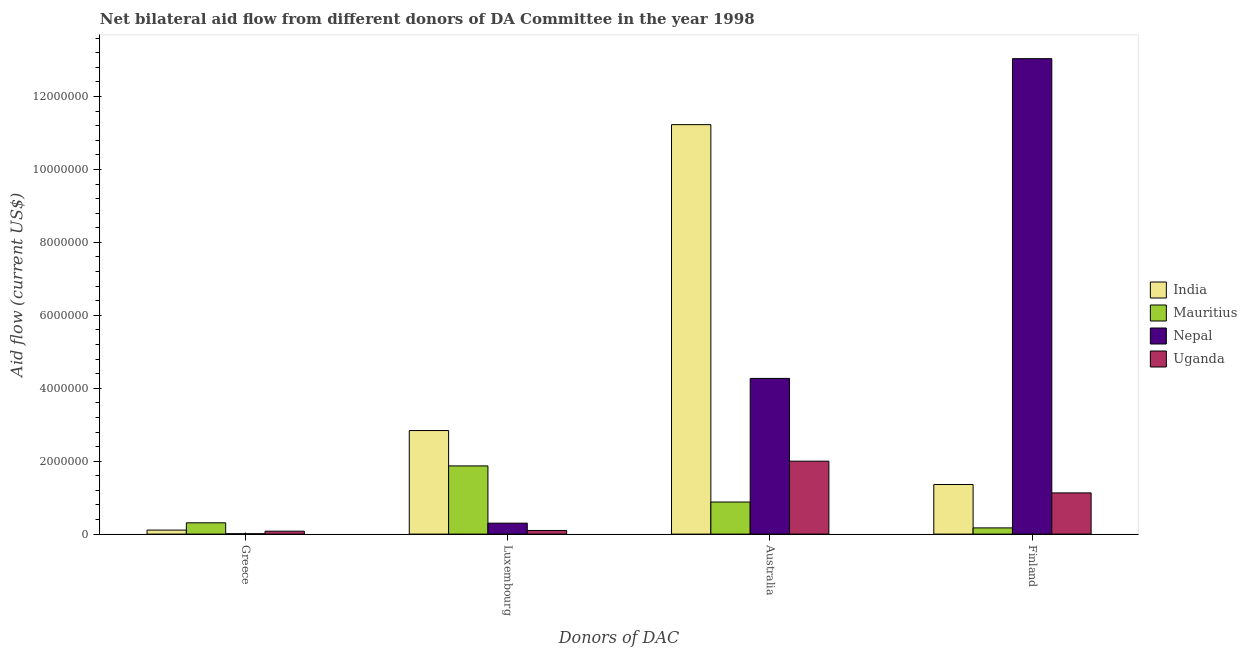What is the amount of aid given by greece in Mauritius?
Your answer should be compact. 3.10e+05. Across all countries, what is the maximum amount of aid given by luxembourg?
Provide a short and direct response. 2.84e+06. Across all countries, what is the minimum amount of aid given by greece?
Make the answer very short. 10000. In which country was the amount of aid given by finland minimum?
Ensure brevity in your answer.  Mauritius. What is the total amount of aid given by finland in the graph?
Your response must be concise. 1.57e+07. What is the difference between the amount of aid given by greece in Mauritius and that in India?
Ensure brevity in your answer.  2.00e+05. What is the difference between the amount of aid given by luxembourg in Nepal and the amount of aid given by finland in Mauritius?
Keep it short and to the point. 1.30e+05. What is the average amount of aid given by australia per country?
Give a very brief answer. 4.60e+06. What is the difference between the amount of aid given by luxembourg and amount of aid given by greece in Mauritius?
Give a very brief answer. 1.56e+06. In how many countries, is the amount of aid given by greece greater than 6400000 US$?
Your response must be concise. 0. What is the ratio of the amount of aid given by luxembourg in Uganda to that in Mauritius?
Give a very brief answer. 0.05. Is the amount of aid given by greece in Mauritius less than that in Nepal?
Provide a succinct answer. No. Is the difference between the amount of aid given by finland in India and Uganda greater than the difference between the amount of aid given by australia in India and Uganda?
Your answer should be compact. No. What is the difference between the highest and the second highest amount of aid given by finland?
Offer a very short reply. 1.17e+07. What is the difference between the highest and the lowest amount of aid given by luxembourg?
Offer a very short reply. 2.74e+06. In how many countries, is the amount of aid given by australia greater than the average amount of aid given by australia taken over all countries?
Offer a terse response. 1. Is it the case that in every country, the sum of the amount of aid given by finland and amount of aid given by luxembourg is greater than the sum of amount of aid given by australia and amount of aid given by greece?
Your answer should be very brief. No. What does the 3rd bar from the left in Australia represents?
Keep it short and to the point. Nepal. What does the 3rd bar from the right in Australia represents?
Your response must be concise. Mauritius. How many bars are there?
Keep it short and to the point. 16. Are all the bars in the graph horizontal?
Your answer should be compact. No. How many countries are there in the graph?
Offer a terse response. 4. Does the graph contain any zero values?
Your answer should be compact. No. How many legend labels are there?
Keep it short and to the point. 4. What is the title of the graph?
Your response must be concise. Net bilateral aid flow from different donors of DA Committee in the year 1998. What is the label or title of the X-axis?
Your answer should be very brief. Donors of DAC. What is the label or title of the Y-axis?
Make the answer very short. Aid flow (current US$). What is the Aid flow (current US$) of Nepal in Greece?
Offer a terse response. 10000. What is the Aid flow (current US$) of Uganda in Greece?
Make the answer very short. 8.00e+04. What is the Aid flow (current US$) of India in Luxembourg?
Offer a very short reply. 2.84e+06. What is the Aid flow (current US$) in Mauritius in Luxembourg?
Provide a short and direct response. 1.87e+06. What is the Aid flow (current US$) of India in Australia?
Your answer should be compact. 1.12e+07. What is the Aid flow (current US$) of Mauritius in Australia?
Offer a very short reply. 8.80e+05. What is the Aid flow (current US$) in Nepal in Australia?
Your answer should be very brief. 4.27e+06. What is the Aid flow (current US$) in India in Finland?
Offer a very short reply. 1.36e+06. What is the Aid flow (current US$) of Nepal in Finland?
Your answer should be very brief. 1.30e+07. What is the Aid flow (current US$) in Uganda in Finland?
Ensure brevity in your answer.  1.13e+06. Across all Donors of DAC, what is the maximum Aid flow (current US$) in India?
Make the answer very short. 1.12e+07. Across all Donors of DAC, what is the maximum Aid flow (current US$) in Mauritius?
Your answer should be compact. 1.87e+06. Across all Donors of DAC, what is the maximum Aid flow (current US$) of Nepal?
Your response must be concise. 1.30e+07. Across all Donors of DAC, what is the maximum Aid flow (current US$) of Uganda?
Ensure brevity in your answer.  2.00e+06. Across all Donors of DAC, what is the minimum Aid flow (current US$) in India?
Give a very brief answer. 1.10e+05. What is the total Aid flow (current US$) of India in the graph?
Provide a short and direct response. 1.55e+07. What is the total Aid flow (current US$) of Mauritius in the graph?
Your answer should be very brief. 3.23e+06. What is the total Aid flow (current US$) of Nepal in the graph?
Your response must be concise. 1.76e+07. What is the total Aid flow (current US$) of Uganda in the graph?
Give a very brief answer. 3.31e+06. What is the difference between the Aid flow (current US$) of India in Greece and that in Luxembourg?
Provide a succinct answer. -2.73e+06. What is the difference between the Aid flow (current US$) in Mauritius in Greece and that in Luxembourg?
Provide a succinct answer. -1.56e+06. What is the difference between the Aid flow (current US$) in Uganda in Greece and that in Luxembourg?
Your response must be concise. -2.00e+04. What is the difference between the Aid flow (current US$) in India in Greece and that in Australia?
Offer a very short reply. -1.11e+07. What is the difference between the Aid flow (current US$) of Mauritius in Greece and that in Australia?
Your answer should be very brief. -5.70e+05. What is the difference between the Aid flow (current US$) in Nepal in Greece and that in Australia?
Offer a very short reply. -4.26e+06. What is the difference between the Aid flow (current US$) of Uganda in Greece and that in Australia?
Your answer should be very brief. -1.92e+06. What is the difference between the Aid flow (current US$) in India in Greece and that in Finland?
Provide a short and direct response. -1.25e+06. What is the difference between the Aid flow (current US$) in Nepal in Greece and that in Finland?
Provide a succinct answer. -1.30e+07. What is the difference between the Aid flow (current US$) of Uganda in Greece and that in Finland?
Offer a very short reply. -1.05e+06. What is the difference between the Aid flow (current US$) of India in Luxembourg and that in Australia?
Give a very brief answer. -8.39e+06. What is the difference between the Aid flow (current US$) of Mauritius in Luxembourg and that in Australia?
Make the answer very short. 9.90e+05. What is the difference between the Aid flow (current US$) in Nepal in Luxembourg and that in Australia?
Offer a very short reply. -3.97e+06. What is the difference between the Aid flow (current US$) in Uganda in Luxembourg and that in Australia?
Keep it short and to the point. -1.90e+06. What is the difference between the Aid flow (current US$) in India in Luxembourg and that in Finland?
Provide a short and direct response. 1.48e+06. What is the difference between the Aid flow (current US$) in Mauritius in Luxembourg and that in Finland?
Provide a succinct answer. 1.70e+06. What is the difference between the Aid flow (current US$) of Nepal in Luxembourg and that in Finland?
Your answer should be compact. -1.27e+07. What is the difference between the Aid flow (current US$) of Uganda in Luxembourg and that in Finland?
Your answer should be compact. -1.03e+06. What is the difference between the Aid flow (current US$) in India in Australia and that in Finland?
Give a very brief answer. 9.87e+06. What is the difference between the Aid flow (current US$) in Mauritius in Australia and that in Finland?
Provide a short and direct response. 7.10e+05. What is the difference between the Aid flow (current US$) of Nepal in Australia and that in Finland?
Make the answer very short. -8.77e+06. What is the difference between the Aid flow (current US$) of Uganda in Australia and that in Finland?
Your answer should be very brief. 8.70e+05. What is the difference between the Aid flow (current US$) of India in Greece and the Aid flow (current US$) of Mauritius in Luxembourg?
Your answer should be compact. -1.76e+06. What is the difference between the Aid flow (current US$) of Mauritius in Greece and the Aid flow (current US$) of Uganda in Luxembourg?
Your answer should be compact. 2.10e+05. What is the difference between the Aid flow (current US$) in Nepal in Greece and the Aid flow (current US$) in Uganda in Luxembourg?
Ensure brevity in your answer.  -9.00e+04. What is the difference between the Aid flow (current US$) in India in Greece and the Aid flow (current US$) in Mauritius in Australia?
Your answer should be very brief. -7.70e+05. What is the difference between the Aid flow (current US$) in India in Greece and the Aid flow (current US$) in Nepal in Australia?
Your answer should be very brief. -4.16e+06. What is the difference between the Aid flow (current US$) in India in Greece and the Aid flow (current US$) in Uganda in Australia?
Offer a terse response. -1.89e+06. What is the difference between the Aid flow (current US$) of Mauritius in Greece and the Aid flow (current US$) of Nepal in Australia?
Provide a short and direct response. -3.96e+06. What is the difference between the Aid flow (current US$) of Mauritius in Greece and the Aid flow (current US$) of Uganda in Australia?
Offer a very short reply. -1.69e+06. What is the difference between the Aid flow (current US$) of Nepal in Greece and the Aid flow (current US$) of Uganda in Australia?
Your answer should be compact. -1.99e+06. What is the difference between the Aid flow (current US$) in India in Greece and the Aid flow (current US$) in Nepal in Finland?
Keep it short and to the point. -1.29e+07. What is the difference between the Aid flow (current US$) in India in Greece and the Aid flow (current US$) in Uganda in Finland?
Ensure brevity in your answer.  -1.02e+06. What is the difference between the Aid flow (current US$) in Mauritius in Greece and the Aid flow (current US$) in Nepal in Finland?
Offer a very short reply. -1.27e+07. What is the difference between the Aid flow (current US$) of Mauritius in Greece and the Aid flow (current US$) of Uganda in Finland?
Offer a terse response. -8.20e+05. What is the difference between the Aid flow (current US$) in Nepal in Greece and the Aid flow (current US$) in Uganda in Finland?
Ensure brevity in your answer.  -1.12e+06. What is the difference between the Aid flow (current US$) in India in Luxembourg and the Aid flow (current US$) in Mauritius in Australia?
Your response must be concise. 1.96e+06. What is the difference between the Aid flow (current US$) in India in Luxembourg and the Aid flow (current US$) in Nepal in Australia?
Your response must be concise. -1.43e+06. What is the difference between the Aid flow (current US$) in India in Luxembourg and the Aid flow (current US$) in Uganda in Australia?
Your answer should be compact. 8.40e+05. What is the difference between the Aid flow (current US$) in Mauritius in Luxembourg and the Aid flow (current US$) in Nepal in Australia?
Your answer should be very brief. -2.40e+06. What is the difference between the Aid flow (current US$) of Mauritius in Luxembourg and the Aid flow (current US$) of Uganda in Australia?
Offer a terse response. -1.30e+05. What is the difference between the Aid flow (current US$) in Nepal in Luxembourg and the Aid flow (current US$) in Uganda in Australia?
Ensure brevity in your answer.  -1.70e+06. What is the difference between the Aid flow (current US$) in India in Luxembourg and the Aid flow (current US$) in Mauritius in Finland?
Provide a short and direct response. 2.67e+06. What is the difference between the Aid flow (current US$) in India in Luxembourg and the Aid flow (current US$) in Nepal in Finland?
Your response must be concise. -1.02e+07. What is the difference between the Aid flow (current US$) in India in Luxembourg and the Aid flow (current US$) in Uganda in Finland?
Offer a terse response. 1.71e+06. What is the difference between the Aid flow (current US$) of Mauritius in Luxembourg and the Aid flow (current US$) of Nepal in Finland?
Your response must be concise. -1.12e+07. What is the difference between the Aid flow (current US$) in Mauritius in Luxembourg and the Aid flow (current US$) in Uganda in Finland?
Offer a terse response. 7.40e+05. What is the difference between the Aid flow (current US$) in Nepal in Luxembourg and the Aid flow (current US$) in Uganda in Finland?
Ensure brevity in your answer.  -8.30e+05. What is the difference between the Aid flow (current US$) of India in Australia and the Aid flow (current US$) of Mauritius in Finland?
Keep it short and to the point. 1.11e+07. What is the difference between the Aid flow (current US$) in India in Australia and the Aid flow (current US$) in Nepal in Finland?
Your answer should be very brief. -1.81e+06. What is the difference between the Aid flow (current US$) in India in Australia and the Aid flow (current US$) in Uganda in Finland?
Give a very brief answer. 1.01e+07. What is the difference between the Aid flow (current US$) of Mauritius in Australia and the Aid flow (current US$) of Nepal in Finland?
Your response must be concise. -1.22e+07. What is the difference between the Aid flow (current US$) in Mauritius in Australia and the Aid flow (current US$) in Uganda in Finland?
Provide a succinct answer. -2.50e+05. What is the difference between the Aid flow (current US$) of Nepal in Australia and the Aid flow (current US$) of Uganda in Finland?
Give a very brief answer. 3.14e+06. What is the average Aid flow (current US$) in India per Donors of DAC?
Give a very brief answer. 3.88e+06. What is the average Aid flow (current US$) of Mauritius per Donors of DAC?
Your response must be concise. 8.08e+05. What is the average Aid flow (current US$) in Nepal per Donors of DAC?
Your response must be concise. 4.40e+06. What is the average Aid flow (current US$) of Uganda per Donors of DAC?
Offer a very short reply. 8.28e+05. What is the difference between the Aid flow (current US$) in India and Aid flow (current US$) in Mauritius in Greece?
Your response must be concise. -2.00e+05. What is the difference between the Aid flow (current US$) of India and Aid flow (current US$) of Nepal in Greece?
Offer a terse response. 1.00e+05. What is the difference between the Aid flow (current US$) in India and Aid flow (current US$) in Uganda in Greece?
Keep it short and to the point. 3.00e+04. What is the difference between the Aid flow (current US$) of Mauritius and Aid flow (current US$) of Nepal in Greece?
Give a very brief answer. 3.00e+05. What is the difference between the Aid flow (current US$) of Mauritius and Aid flow (current US$) of Uganda in Greece?
Make the answer very short. 2.30e+05. What is the difference between the Aid flow (current US$) of India and Aid flow (current US$) of Mauritius in Luxembourg?
Make the answer very short. 9.70e+05. What is the difference between the Aid flow (current US$) of India and Aid flow (current US$) of Nepal in Luxembourg?
Provide a succinct answer. 2.54e+06. What is the difference between the Aid flow (current US$) of India and Aid flow (current US$) of Uganda in Luxembourg?
Your answer should be very brief. 2.74e+06. What is the difference between the Aid flow (current US$) in Mauritius and Aid flow (current US$) in Nepal in Luxembourg?
Your answer should be compact. 1.57e+06. What is the difference between the Aid flow (current US$) of Mauritius and Aid flow (current US$) of Uganda in Luxembourg?
Provide a short and direct response. 1.77e+06. What is the difference between the Aid flow (current US$) of India and Aid flow (current US$) of Mauritius in Australia?
Ensure brevity in your answer.  1.04e+07. What is the difference between the Aid flow (current US$) of India and Aid flow (current US$) of Nepal in Australia?
Your answer should be very brief. 6.96e+06. What is the difference between the Aid flow (current US$) in India and Aid flow (current US$) in Uganda in Australia?
Keep it short and to the point. 9.23e+06. What is the difference between the Aid flow (current US$) in Mauritius and Aid flow (current US$) in Nepal in Australia?
Offer a terse response. -3.39e+06. What is the difference between the Aid flow (current US$) in Mauritius and Aid flow (current US$) in Uganda in Australia?
Offer a very short reply. -1.12e+06. What is the difference between the Aid flow (current US$) of Nepal and Aid flow (current US$) of Uganda in Australia?
Ensure brevity in your answer.  2.27e+06. What is the difference between the Aid flow (current US$) in India and Aid flow (current US$) in Mauritius in Finland?
Keep it short and to the point. 1.19e+06. What is the difference between the Aid flow (current US$) in India and Aid flow (current US$) in Nepal in Finland?
Offer a terse response. -1.17e+07. What is the difference between the Aid flow (current US$) in Mauritius and Aid flow (current US$) in Nepal in Finland?
Your answer should be very brief. -1.29e+07. What is the difference between the Aid flow (current US$) of Mauritius and Aid flow (current US$) of Uganda in Finland?
Offer a very short reply. -9.60e+05. What is the difference between the Aid flow (current US$) of Nepal and Aid flow (current US$) of Uganda in Finland?
Give a very brief answer. 1.19e+07. What is the ratio of the Aid flow (current US$) in India in Greece to that in Luxembourg?
Your answer should be very brief. 0.04. What is the ratio of the Aid flow (current US$) of Mauritius in Greece to that in Luxembourg?
Provide a short and direct response. 0.17. What is the ratio of the Aid flow (current US$) of Nepal in Greece to that in Luxembourg?
Your response must be concise. 0.03. What is the ratio of the Aid flow (current US$) in Uganda in Greece to that in Luxembourg?
Provide a succinct answer. 0.8. What is the ratio of the Aid flow (current US$) in India in Greece to that in Australia?
Your answer should be very brief. 0.01. What is the ratio of the Aid flow (current US$) in Mauritius in Greece to that in Australia?
Offer a terse response. 0.35. What is the ratio of the Aid flow (current US$) in Nepal in Greece to that in Australia?
Give a very brief answer. 0. What is the ratio of the Aid flow (current US$) in Uganda in Greece to that in Australia?
Your response must be concise. 0.04. What is the ratio of the Aid flow (current US$) of India in Greece to that in Finland?
Ensure brevity in your answer.  0.08. What is the ratio of the Aid flow (current US$) of Mauritius in Greece to that in Finland?
Offer a terse response. 1.82. What is the ratio of the Aid flow (current US$) of Nepal in Greece to that in Finland?
Provide a succinct answer. 0. What is the ratio of the Aid flow (current US$) in Uganda in Greece to that in Finland?
Ensure brevity in your answer.  0.07. What is the ratio of the Aid flow (current US$) of India in Luxembourg to that in Australia?
Offer a terse response. 0.25. What is the ratio of the Aid flow (current US$) in Mauritius in Luxembourg to that in Australia?
Ensure brevity in your answer.  2.12. What is the ratio of the Aid flow (current US$) of Nepal in Luxembourg to that in Australia?
Your response must be concise. 0.07. What is the ratio of the Aid flow (current US$) of India in Luxembourg to that in Finland?
Keep it short and to the point. 2.09. What is the ratio of the Aid flow (current US$) in Nepal in Luxembourg to that in Finland?
Give a very brief answer. 0.02. What is the ratio of the Aid flow (current US$) of Uganda in Luxembourg to that in Finland?
Ensure brevity in your answer.  0.09. What is the ratio of the Aid flow (current US$) of India in Australia to that in Finland?
Give a very brief answer. 8.26. What is the ratio of the Aid flow (current US$) of Mauritius in Australia to that in Finland?
Your answer should be very brief. 5.18. What is the ratio of the Aid flow (current US$) of Nepal in Australia to that in Finland?
Your answer should be very brief. 0.33. What is the ratio of the Aid flow (current US$) in Uganda in Australia to that in Finland?
Ensure brevity in your answer.  1.77. What is the difference between the highest and the second highest Aid flow (current US$) of India?
Offer a very short reply. 8.39e+06. What is the difference between the highest and the second highest Aid flow (current US$) in Mauritius?
Your answer should be very brief. 9.90e+05. What is the difference between the highest and the second highest Aid flow (current US$) in Nepal?
Provide a short and direct response. 8.77e+06. What is the difference between the highest and the second highest Aid flow (current US$) of Uganda?
Give a very brief answer. 8.70e+05. What is the difference between the highest and the lowest Aid flow (current US$) of India?
Offer a very short reply. 1.11e+07. What is the difference between the highest and the lowest Aid flow (current US$) in Mauritius?
Give a very brief answer. 1.70e+06. What is the difference between the highest and the lowest Aid flow (current US$) in Nepal?
Make the answer very short. 1.30e+07. What is the difference between the highest and the lowest Aid flow (current US$) in Uganda?
Offer a very short reply. 1.92e+06. 